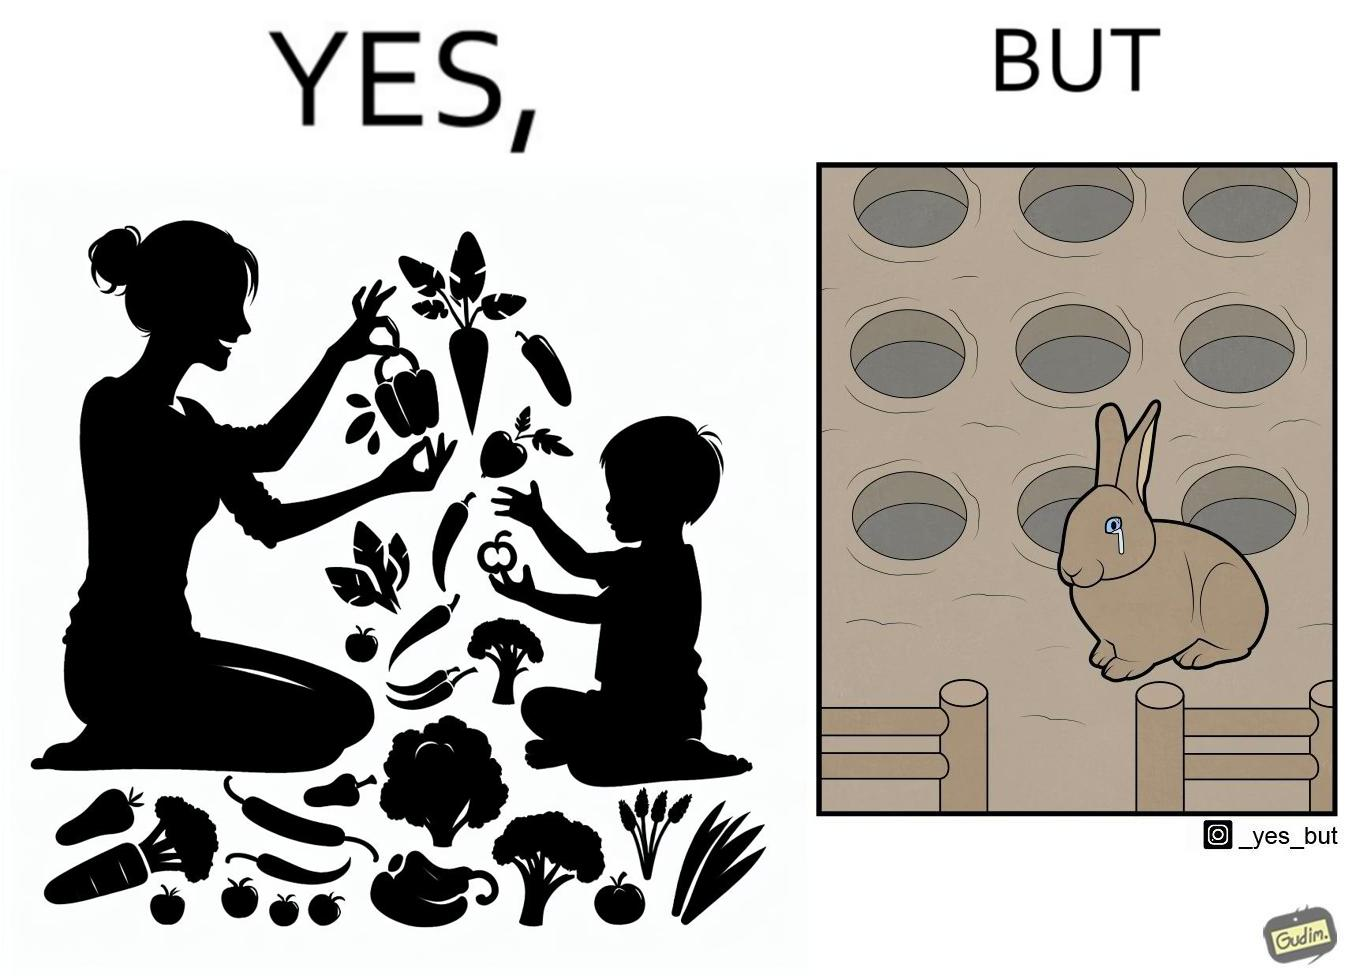Explain the humor or irony in this image. The images are ironic since they show how on one hand humans choose to play with and waste foods like vegetables while the animals are unable to eat enough food and end up starving due to lack of food 